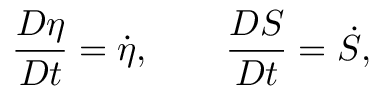Convert formula to latex. <formula><loc_0><loc_0><loc_500><loc_500>\frac { D \eta } { D t } = \dot { \eta } , \quad \frac { D S } { D t } = \dot { S } ,</formula> 